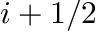Convert formula to latex. <formula><loc_0><loc_0><loc_500><loc_500>i + 1 / 2</formula> 